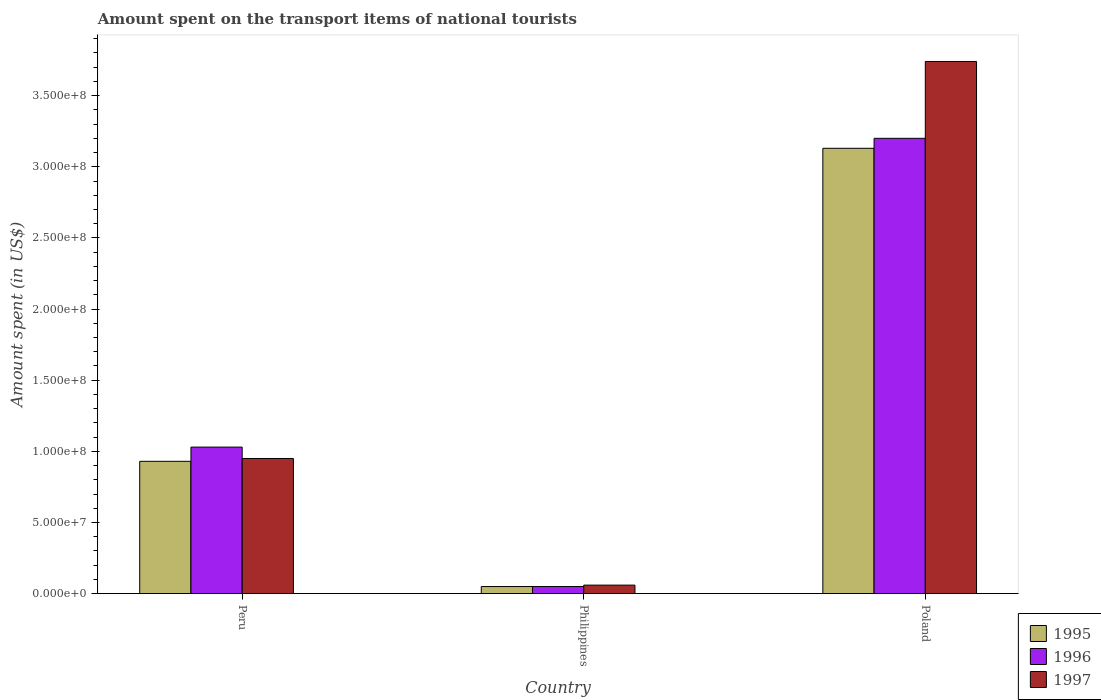How many different coloured bars are there?
Give a very brief answer. 3. How many groups of bars are there?
Provide a short and direct response. 3. How many bars are there on the 3rd tick from the left?
Your response must be concise. 3. What is the label of the 2nd group of bars from the left?
Your answer should be compact. Philippines. In how many cases, is the number of bars for a given country not equal to the number of legend labels?
Ensure brevity in your answer.  0. What is the amount spent on the transport items of national tourists in 1997 in Poland?
Your answer should be compact. 3.74e+08. Across all countries, what is the maximum amount spent on the transport items of national tourists in 1995?
Provide a succinct answer. 3.13e+08. What is the total amount spent on the transport items of national tourists in 1995 in the graph?
Your answer should be compact. 4.11e+08. What is the difference between the amount spent on the transport items of national tourists in 1997 in Philippines and that in Poland?
Your response must be concise. -3.68e+08. What is the difference between the amount spent on the transport items of national tourists in 1996 in Peru and the amount spent on the transport items of national tourists in 1995 in Philippines?
Make the answer very short. 9.80e+07. What is the average amount spent on the transport items of national tourists in 1996 per country?
Make the answer very short. 1.43e+08. In how many countries, is the amount spent on the transport items of national tourists in 1997 greater than 340000000 US$?
Your answer should be very brief. 1. What is the ratio of the amount spent on the transport items of national tourists in 1995 in Philippines to that in Poland?
Provide a succinct answer. 0.02. Is the amount spent on the transport items of national tourists in 1997 in Peru less than that in Philippines?
Offer a terse response. No. What is the difference between the highest and the second highest amount spent on the transport items of national tourists in 1997?
Make the answer very short. 3.68e+08. What is the difference between the highest and the lowest amount spent on the transport items of national tourists in 1995?
Your response must be concise. 3.08e+08. Is the sum of the amount spent on the transport items of national tourists in 1996 in Peru and Philippines greater than the maximum amount spent on the transport items of national tourists in 1995 across all countries?
Give a very brief answer. No. What does the 1st bar from the right in Poland represents?
Provide a succinct answer. 1997. Is it the case that in every country, the sum of the amount spent on the transport items of national tourists in 1995 and amount spent on the transport items of national tourists in 1997 is greater than the amount spent on the transport items of national tourists in 1996?
Give a very brief answer. Yes. Are the values on the major ticks of Y-axis written in scientific E-notation?
Your answer should be very brief. Yes. Does the graph contain grids?
Offer a very short reply. No. Where does the legend appear in the graph?
Make the answer very short. Bottom right. How many legend labels are there?
Your answer should be very brief. 3. What is the title of the graph?
Your response must be concise. Amount spent on the transport items of national tourists. What is the label or title of the X-axis?
Provide a short and direct response. Country. What is the label or title of the Y-axis?
Give a very brief answer. Amount spent (in US$). What is the Amount spent (in US$) of 1995 in Peru?
Make the answer very short. 9.30e+07. What is the Amount spent (in US$) of 1996 in Peru?
Give a very brief answer. 1.03e+08. What is the Amount spent (in US$) of 1997 in Peru?
Make the answer very short. 9.50e+07. What is the Amount spent (in US$) of 1995 in Philippines?
Provide a succinct answer. 5.00e+06. What is the Amount spent (in US$) in 1996 in Philippines?
Provide a short and direct response. 5.00e+06. What is the Amount spent (in US$) in 1995 in Poland?
Provide a short and direct response. 3.13e+08. What is the Amount spent (in US$) in 1996 in Poland?
Ensure brevity in your answer.  3.20e+08. What is the Amount spent (in US$) in 1997 in Poland?
Provide a short and direct response. 3.74e+08. Across all countries, what is the maximum Amount spent (in US$) of 1995?
Offer a terse response. 3.13e+08. Across all countries, what is the maximum Amount spent (in US$) of 1996?
Keep it short and to the point. 3.20e+08. Across all countries, what is the maximum Amount spent (in US$) in 1997?
Keep it short and to the point. 3.74e+08. Across all countries, what is the minimum Amount spent (in US$) of 1996?
Keep it short and to the point. 5.00e+06. Across all countries, what is the minimum Amount spent (in US$) of 1997?
Provide a succinct answer. 6.00e+06. What is the total Amount spent (in US$) of 1995 in the graph?
Provide a succinct answer. 4.11e+08. What is the total Amount spent (in US$) of 1996 in the graph?
Offer a very short reply. 4.28e+08. What is the total Amount spent (in US$) in 1997 in the graph?
Your answer should be compact. 4.75e+08. What is the difference between the Amount spent (in US$) of 1995 in Peru and that in Philippines?
Your response must be concise. 8.80e+07. What is the difference between the Amount spent (in US$) of 1996 in Peru and that in Philippines?
Your answer should be compact. 9.80e+07. What is the difference between the Amount spent (in US$) in 1997 in Peru and that in Philippines?
Provide a short and direct response. 8.90e+07. What is the difference between the Amount spent (in US$) of 1995 in Peru and that in Poland?
Give a very brief answer. -2.20e+08. What is the difference between the Amount spent (in US$) of 1996 in Peru and that in Poland?
Offer a terse response. -2.17e+08. What is the difference between the Amount spent (in US$) in 1997 in Peru and that in Poland?
Provide a succinct answer. -2.79e+08. What is the difference between the Amount spent (in US$) of 1995 in Philippines and that in Poland?
Provide a succinct answer. -3.08e+08. What is the difference between the Amount spent (in US$) of 1996 in Philippines and that in Poland?
Offer a terse response. -3.15e+08. What is the difference between the Amount spent (in US$) of 1997 in Philippines and that in Poland?
Ensure brevity in your answer.  -3.68e+08. What is the difference between the Amount spent (in US$) in 1995 in Peru and the Amount spent (in US$) in 1996 in Philippines?
Your answer should be very brief. 8.80e+07. What is the difference between the Amount spent (in US$) of 1995 in Peru and the Amount spent (in US$) of 1997 in Philippines?
Offer a very short reply. 8.70e+07. What is the difference between the Amount spent (in US$) of 1996 in Peru and the Amount spent (in US$) of 1997 in Philippines?
Provide a succinct answer. 9.70e+07. What is the difference between the Amount spent (in US$) of 1995 in Peru and the Amount spent (in US$) of 1996 in Poland?
Provide a short and direct response. -2.27e+08. What is the difference between the Amount spent (in US$) in 1995 in Peru and the Amount spent (in US$) in 1997 in Poland?
Make the answer very short. -2.81e+08. What is the difference between the Amount spent (in US$) in 1996 in Peru and the Amount spent (in US$) in 1997 in Poland?
Provide a short and direct response. -2.71e+08. What is the difference between the Amount spent (in US$) in 1995 in Philippines and the Amount spent (in US$) in 1996 in Poland?
Offer a terse response. -3.15e+08. What is the difference between the Amount spent (in US$) of 1995 in Philippines and the Amount spent (in US$) of 1997 in Poland?
Provide a succinct answer. -3.69e+08. What is the difference between the Amount spent (in US$) of 1996 in Philippines and the Amount spent (in US$) of 1997 in Poland?
Offer a very short reply. -3.69e+08. What is the average Amount spent (in US$) in 1995 per country?
Offer a terse response. 1.37e+08. What is the average Amount spent (in US$) in 1996 per country?
Offer a terse response. 1.43e+08. What is the average Amount spent (in US$) in 1997 per country?
Offer a terse response. 1.58e+08. What is the difference between the Amount spent (in US$) in 1995 and Amount spent (in US$) in 1996 in Peru?
Your answer should be very brief. -1.00e+07. What is the difference between the Amount spent (in US$) in 1996 and Amount spent (in US$) in 1997 in Peru?
Offer a terse response. 8.00e+06. What is the difference between the Amount spent (in US$) in 1995 and Amount spent (in US$) in 1996 in Philippines?
Give a very brief answer. 0. What is the difference between the Amount spent (in US$) of 1995 and Amount spent (in US$) of 1997 in Philippines?
Keep it short and to the point. -1.00e+06. What is the difference between the Amount spent (in US$) in 1995 and Amount spent (in US$) in 1996 in Poland?
Your answer should be compact. -7.00e+06. What is the difference between the Amount spent (in US$) of 1995 and Amount spent (in US$) of 1997 in Poland?
Make the answer very short. -6.10e+07. What is the difference between the Amount spent (in US$) in 1996 and Amount spent (in US$) in 1997 in Poland?
Provide a short and direct response. -5.40e+07. What is the ratio of the Amount spent (in US$) of 1995 in Peru to that in Philippines?
Provide a succinct answer. 18.6. What is the ratio of the Amount spent (in US$) of 1996 in Peru to that in Philippines?
Your answer should be very brief. 20.6. What is the ratio of the Amount spent (in US$) of 1997 in Peru to that in Philippines?
Your response must be concise. 15.83. What is the ratio of the Amount spent (in US$) of 1995 in Peru to that in Poland?
Offer a very short reply. 0.3. What is the ratio of the Amount spent (in US$) in 1996 in Peru to that in Poland?
Make the answer very short. 0.32. What is the ratio of the Amount spent (in US$) of 1997 in Peru to that in Poland?
Offer a very short reply. 0.25. What is the ratio of the Amount spent (in US$) of 1995 in Philippines to that in Poland?
Provide a short and direct response. 0.02. What is the ratio of the Amount spent (in US$) of 1996 in Philippines to that in Poland?
Give a very brief answer. 0.02. What is the ratio of the Amount spent (in US$) in 1997 in Philippines to that in Poland?
Give a very brief answer. 0.02. What is the difference between the highest and the second highest Amount spent (in US$) of 1995?
Keep it short and to the point. 2.20e+08. What is the difference between the highest and the second highest Amount spent (in US$) of 1996?
Offer a very short reply. 2.17e+08. What is the difference between the highest and the second highest Amount spent (in US$) in 1997?
Provide a short and direct response. 2.79e+08. What is the difference between the highest and the lowest Amount spent (in US$) in 1995?
Offer a terse response. 3.08e+08. What is the difference between the highest and the lowest Amount spent (in US$) in 1996?
Offer a very short reply. 3.15e+08. What is the difference between the highest and the lowest Amount spent (in US$) of 1997?
Offer a terse response. 3.68e+08. 